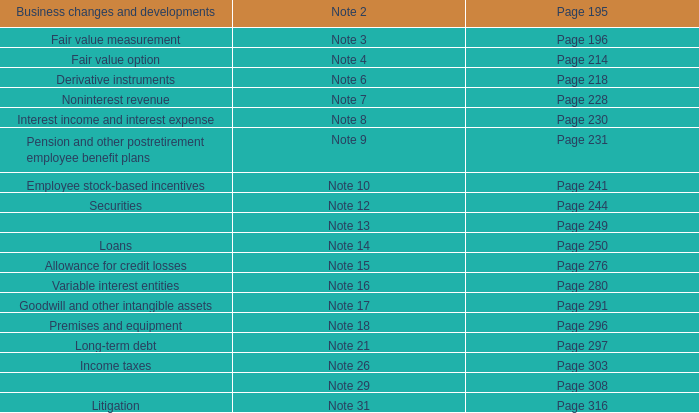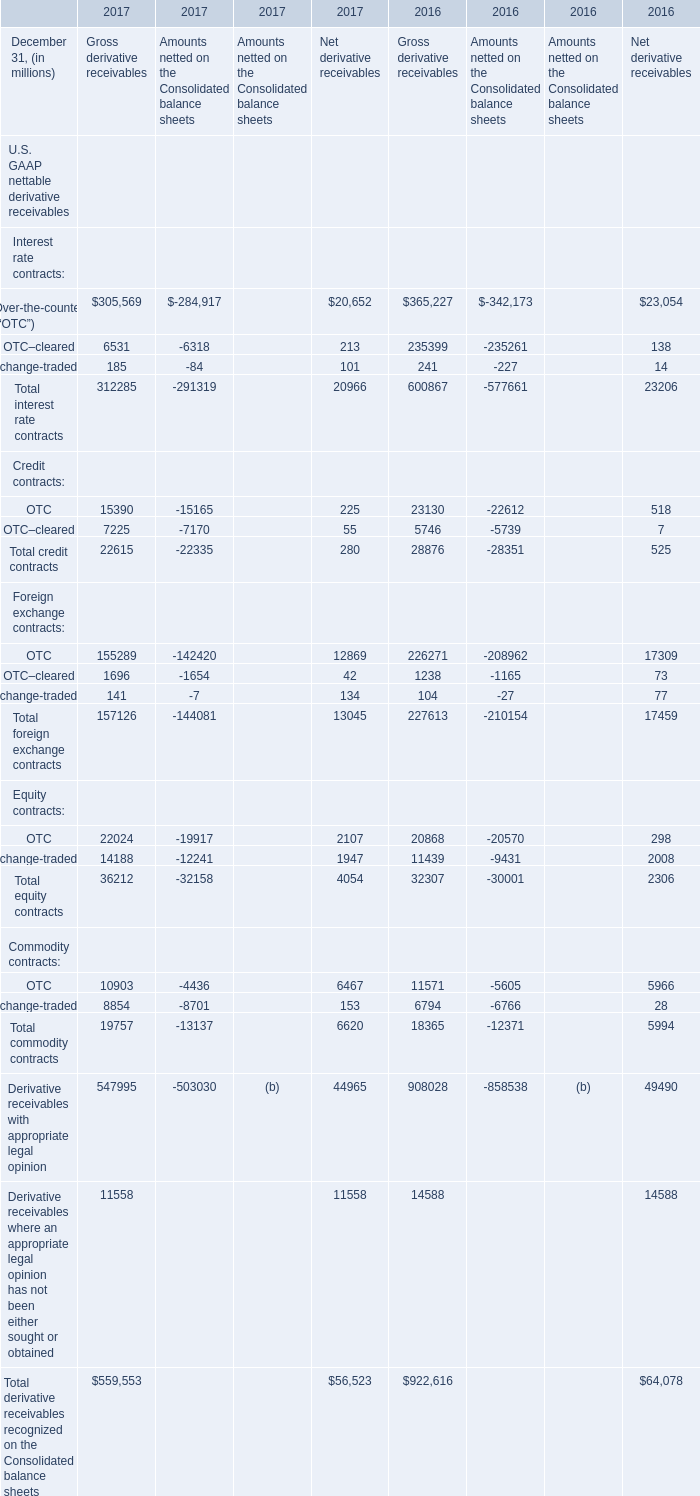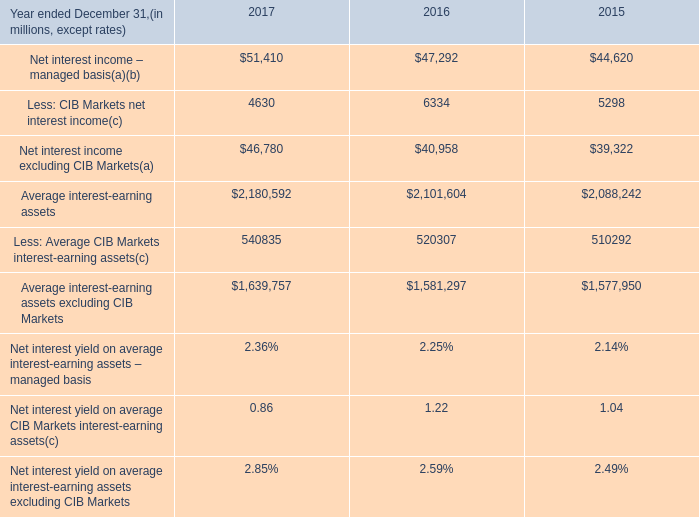what was the percentage change in the average interest-earning assets excluding cib markets in 2017 
Computations: ((1639757 - 1581297) / 1581297)
Answer: 0.03697. 